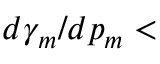Convert formula to latex. <formula><loc_0><loc_0><loc_500><loc_500>d \gamma _ { m } / d p _ { m } <</formula> 